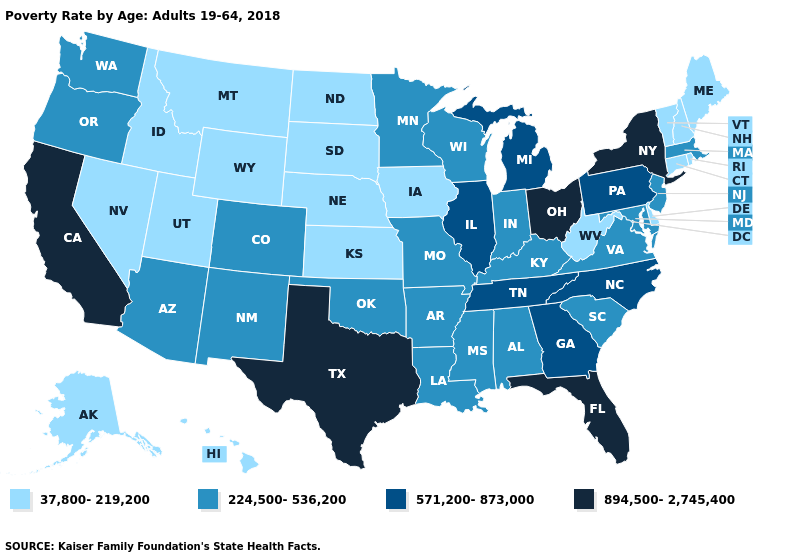What is the lowest value in states that border Minnesota?
Write a very short answer. 37,800-219,200. Name the states that have a value in the range 571,200-873,000?
Concise answer only. Georgia, Illinois, Michigan, North Carolina, Pennsylvania, Tennessee. Does Tennessee have the same value as Florida?
Keep it brief. No. What is the highest value in states that border Rhode Island?
Concise answer only. 224,500-536,200. Name the states that have a value in the range 224,500-536,200?
Be succinct. Alabama, Arizona, Arkansas, Colorado, Indiana, Kentucky, Louisiana, Maryland, Massachusetts, Minnesota, Mississippi, Missouri, New Jersey, New Mexico, Oklahoma, Oregon, South Carolina, Virginia, Washington, Wisconsin. What is the value of Connecticut?
Keep it brief. 37,800-219,200. What is the highest value in the Northeast ?
Short answer required. 894,500-2,745,400. Name the states that have a value in the range 37,800-219,200?
Keep it brief. Alaska, Connecticut, Delaware, Hawaii, Idaho, Iowa, Kansas, Maine, Montana, Nebraska, Nevada, New Hampshire, North Dakota, Rhode Island, South Dakota, Utah, Vermont, West Virginia, Wyoming. What is the value of Missouri?
Answer briefly. 224,500-536,200. Does the map have missing data?
Be succinct. No. What is the highest value in the South ?
Answer briefly. 894,500-2,745,400. What is the highest value in the USA?
Answer briefly. 894,500-2,745,400. What is the lowest value in states that border Mississippi?
Answer briefly. 224,500-536,200. Does the map have missing data?
Be succinct. No. Among the states that border Alabama , does Florida have the highest value?
Give a very brief answer. Yes. 